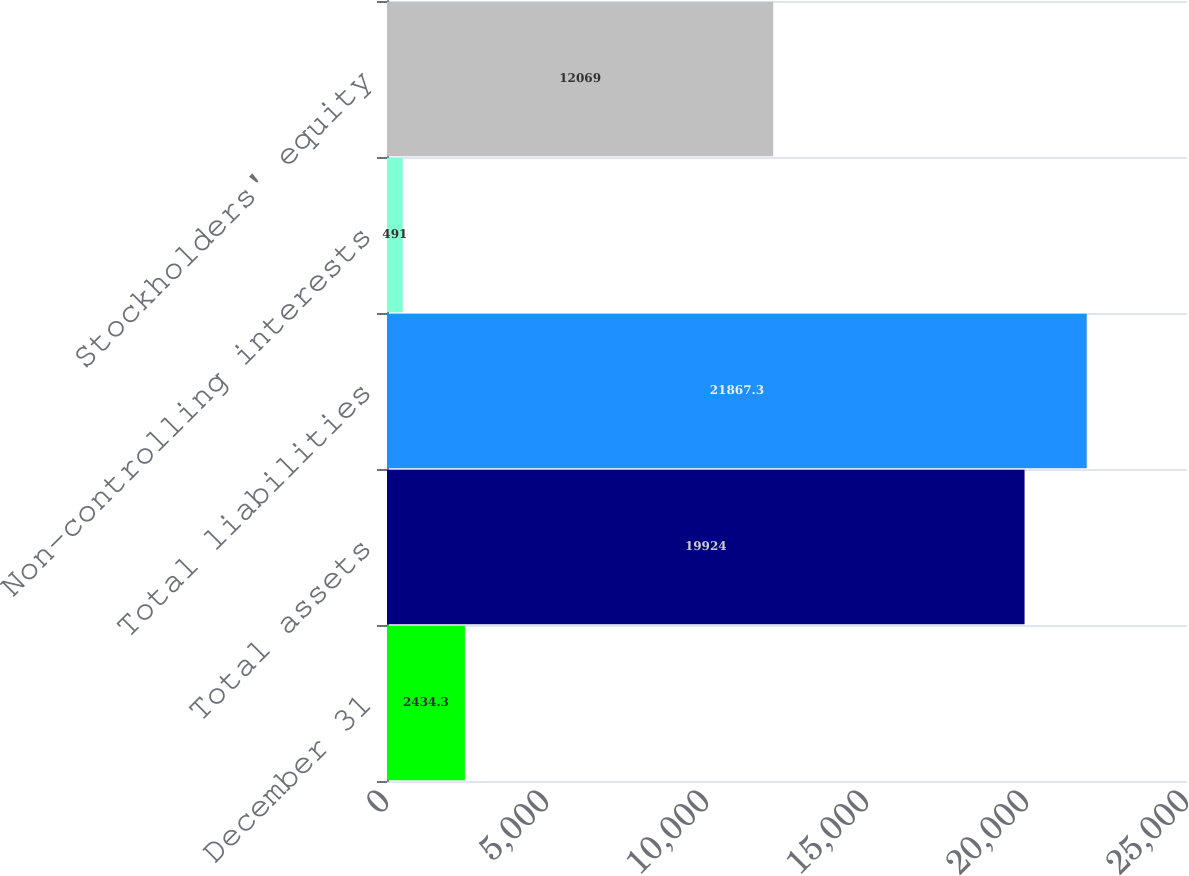Convert chart to OTSL. <chart><loc_0><loc_0><loc_500><loc_500><bar_chart><fcel>December 31<fcel>Total assets<fcel>Total liabilities<fcel>Non-controlling interests<fcel>Stockholders' equity<nl><fcel>2434.3<fcel>19924<fcel>21867.3<fcel>491<fcel>12069<nl></chart> 